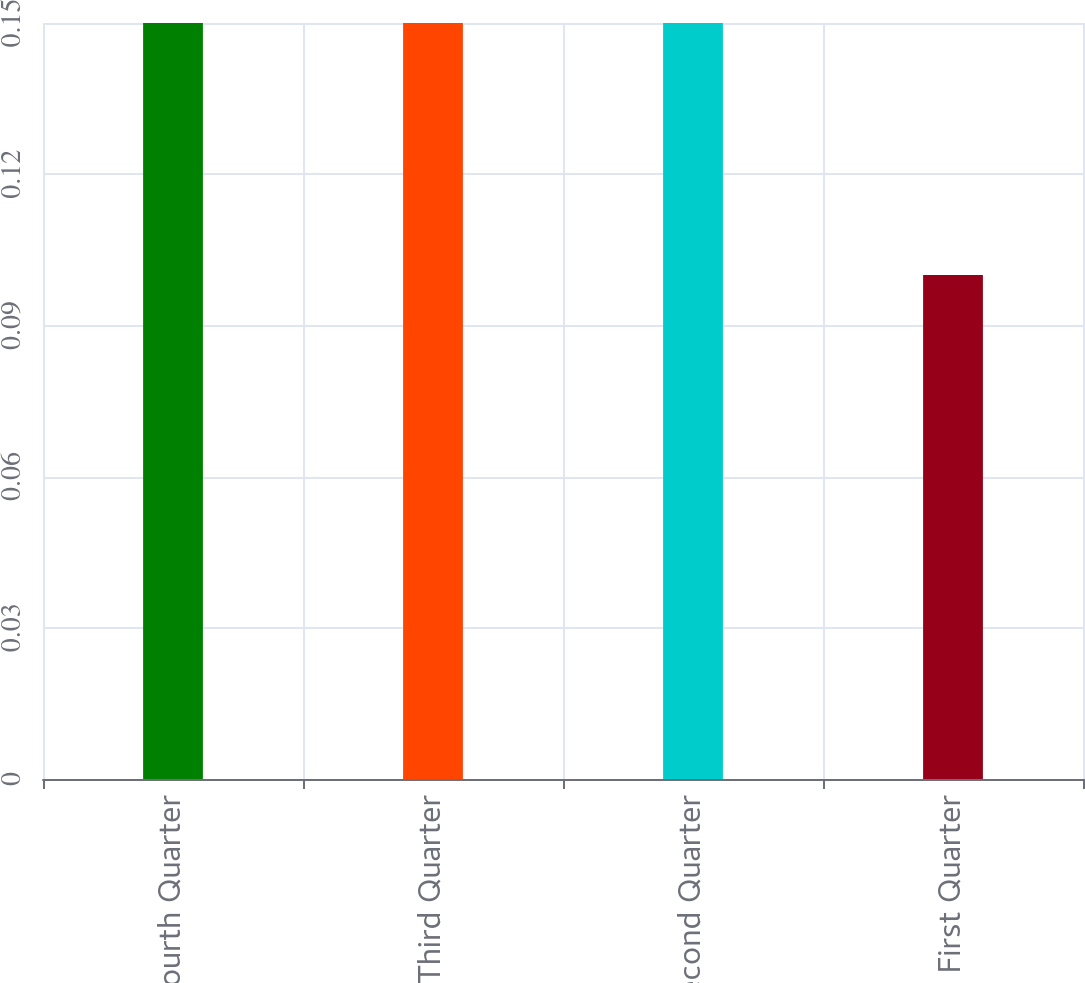Convert chart to OTSL. <chart><loc_0><loc_0><loc_500><loc_500><bar_chart><fcel>Fourth Quarter<fcel>Third Quarter<fcel>Second Quarter<fcel>First Quarter<nl><fcel>0.15<fcel>0.15<fcel>0.15<fcel>0.1<nl></chart> 